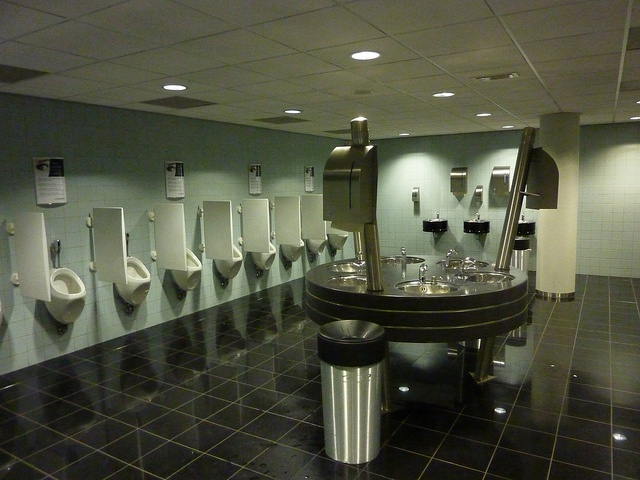Describe the objects in this image and their specific colors. I can see toilet in black, gray, darkgreen, and darkgray tones, toilet in black, gray, darkgreen, and beige tones, toilet in black, gray, darkgreen, and beige tones, sink in black, gray, olive, darkgray, and darkgreen tones, and sink in black, gray, darkgreen, and darkgray tones in this image. 